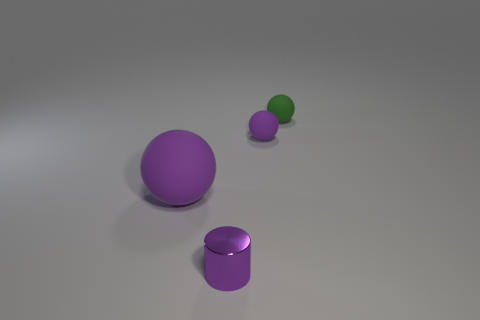How many objects are big rubber objects or tiny objects that are behind the tiny shiny cylinder?
Your answer should be very brief. 3. Are there any other small things that have the same shape as the tiny purple metal thing?
Offer a terse response. No. Is the number of purple rubber balls in front of the metal cylinder the same as the number of tiny metal objects in front of the big purple object?
Provide a short and direct response. No. What number of gray objects are either cylinders or large matte objects?
Ensure brevity in your answer.  0. How many purple matte things have the same size as the metallic cylinder?
Provide a short and direct response. 1. There is a ball that is both on the left side of the small green rubber sphere and on the right side of the big matte sphere; what is its color?
Your response must be concise. Purple. Are there more small matte objects in front of the green rubber object than blue things?
Ensure brevity in your answer.  Yes. Are any small blue shiny cylinders visible?
Offer a very short reply. No. What number of tiny objects are either shiny cylinders or rubber balls?
Make the answer very short. 3. Is there anything else of the same color as the small metal cylinder?
Provide a succinct answer. Yes. 